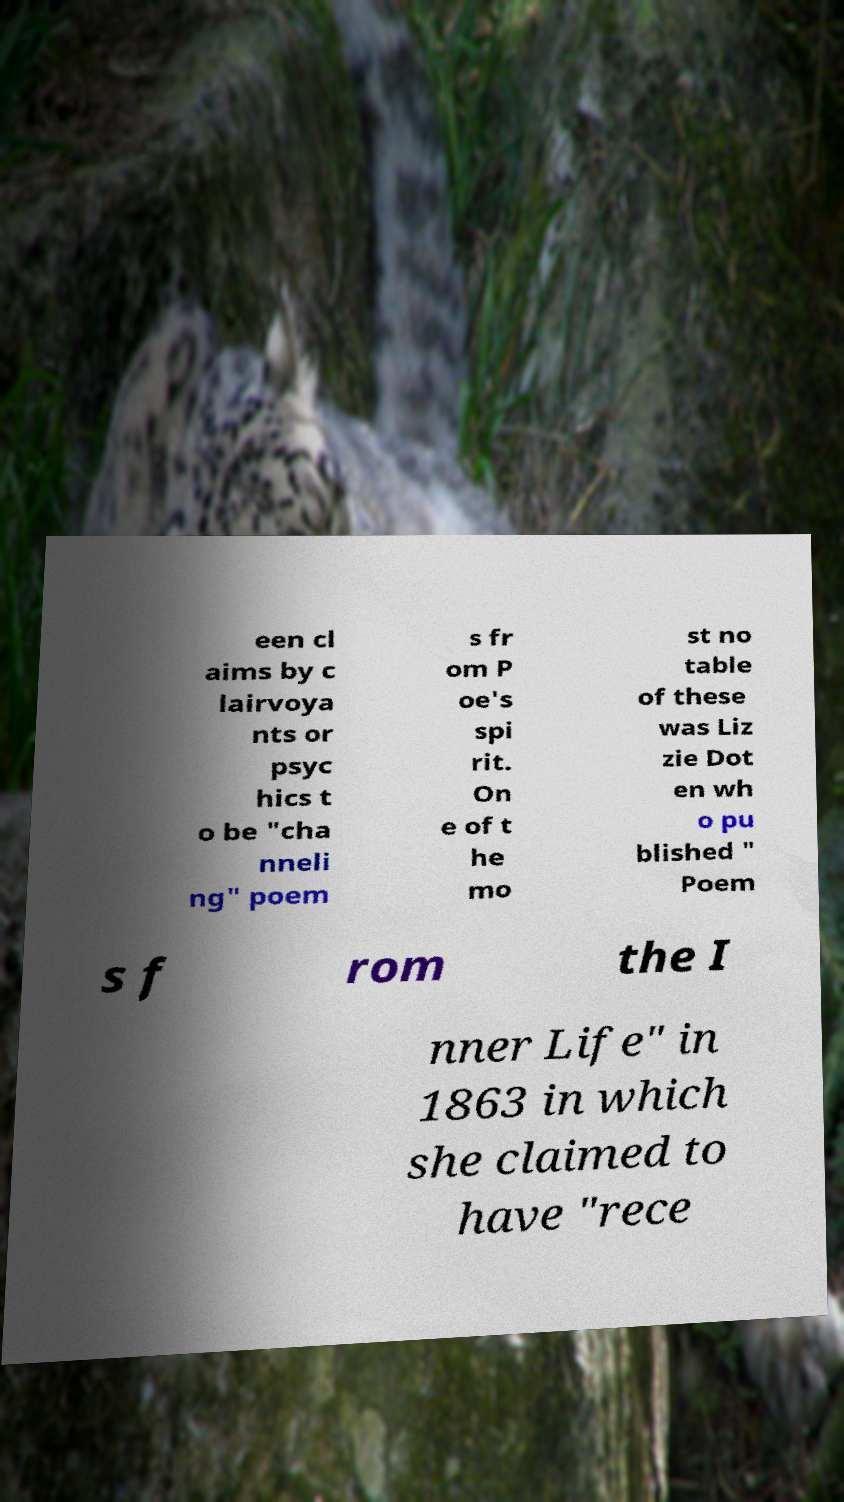Can you read and provide the text displayed in the image?This photo seems to have some interesting text. Can you extract and type it out for me? een cl aims by c lairvoya nts or psyc hics t o be "cha nneli ng" poem s fr om P oe's spi rit. On e of t he mo st no table of these was Liz zie Dot en wh o pu blished " Poem s f rom the I nner Life" in 1863 in which she claimed to have "rece 